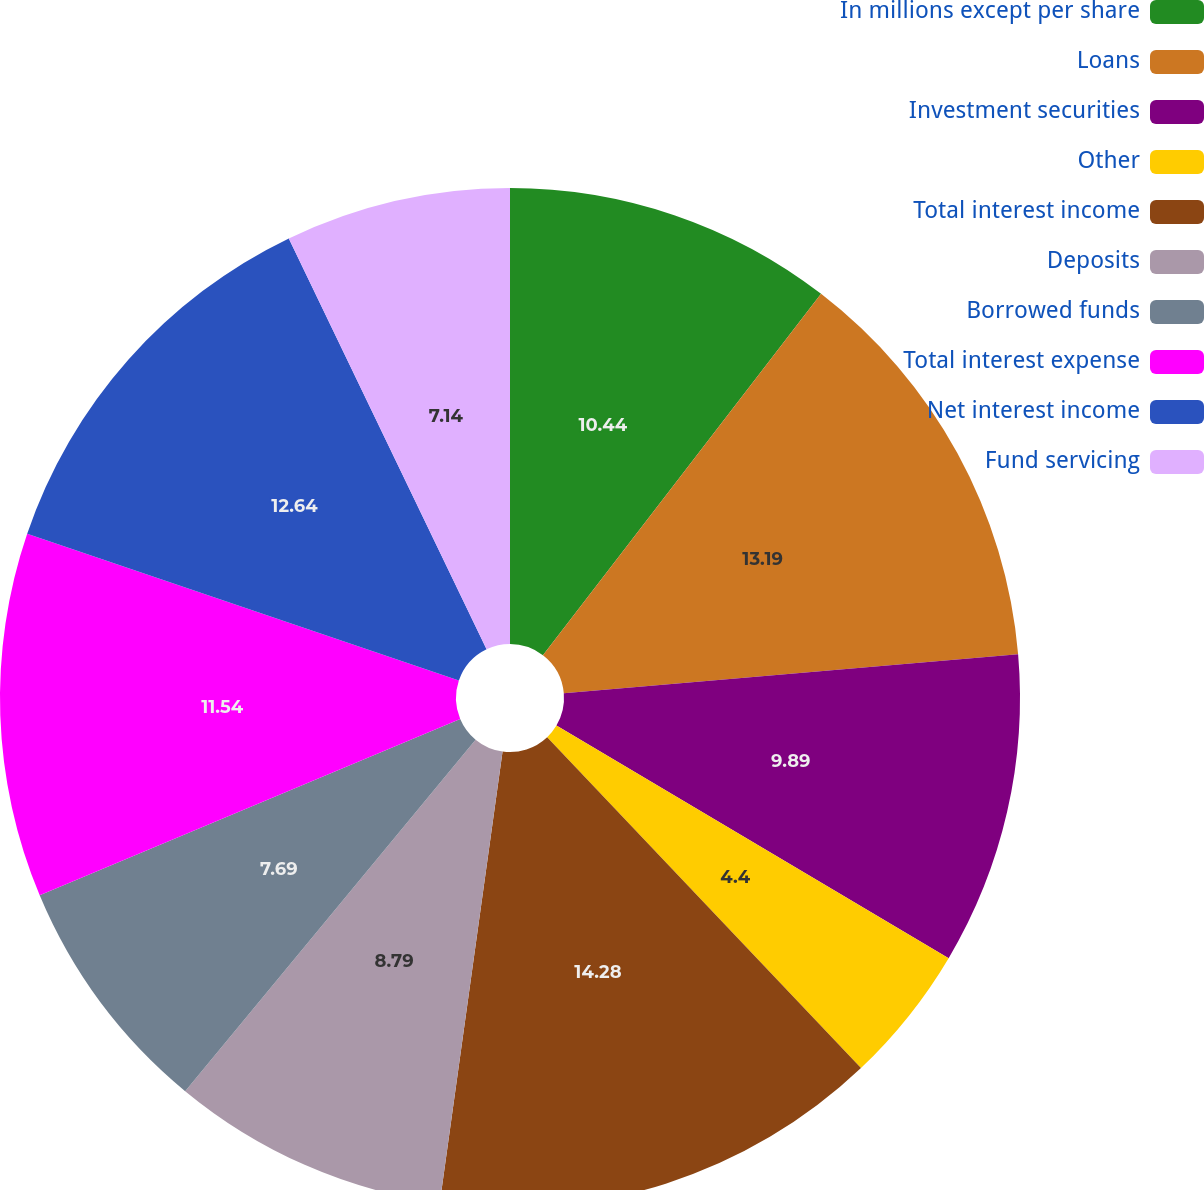Convert chart to OTSL. <chart><loc_0><loc_0><loc_500><loc_500><pie_chart><fcel>In millions except per share<fcel>Loans<fcel>Investment securities<fcel>Other<fcel>Total interest income<fcel>Deposits<fcel>Borrowed funds<fcel>Total interest expense<fcel>Net interest income<fcel>Fund servicing<nl><fcel>10.44%<fcel>13.19%<fcel>9.89%<fcel>4.4%<fcel>14.28%<fcel>8.79%<fcel>7.69%<fcel>11.54%<fcel>12.64%<fcel>7.14%<nl></chart> 